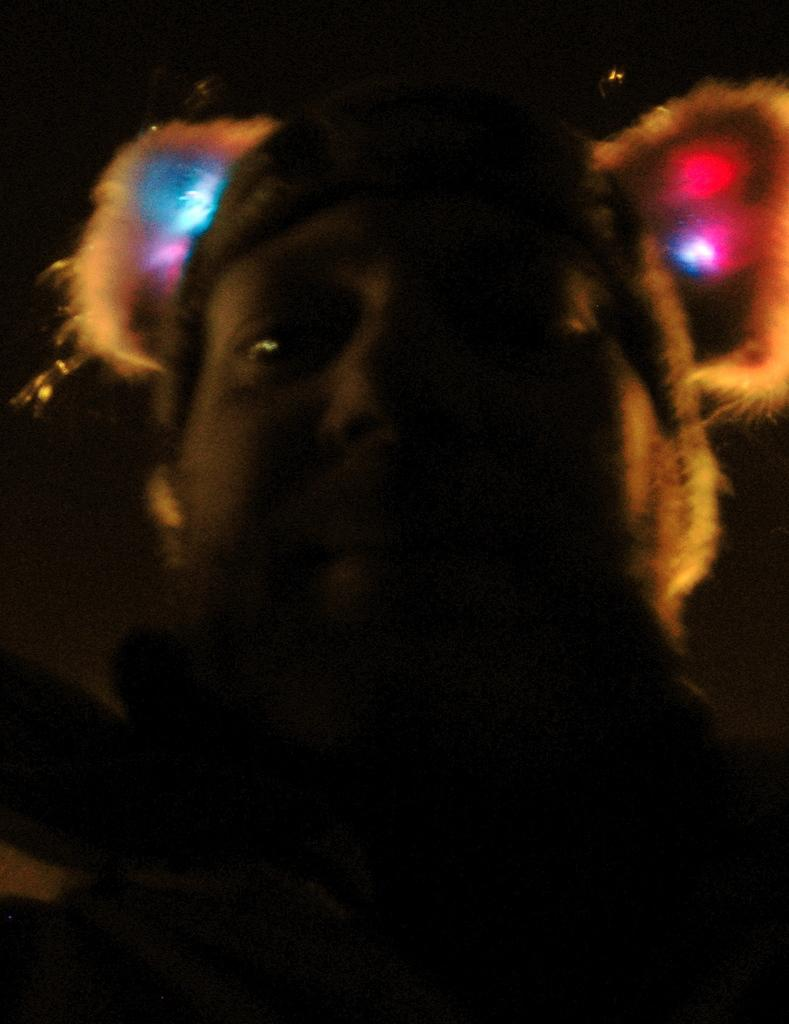What is the main subject of the image? There is a person in the image. What type of ring is the person wearing in the image? There is no ring visible on the person in the image. 